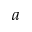<formula> <loc_0><loc_0><loc_500><loc_500>a</formula> 